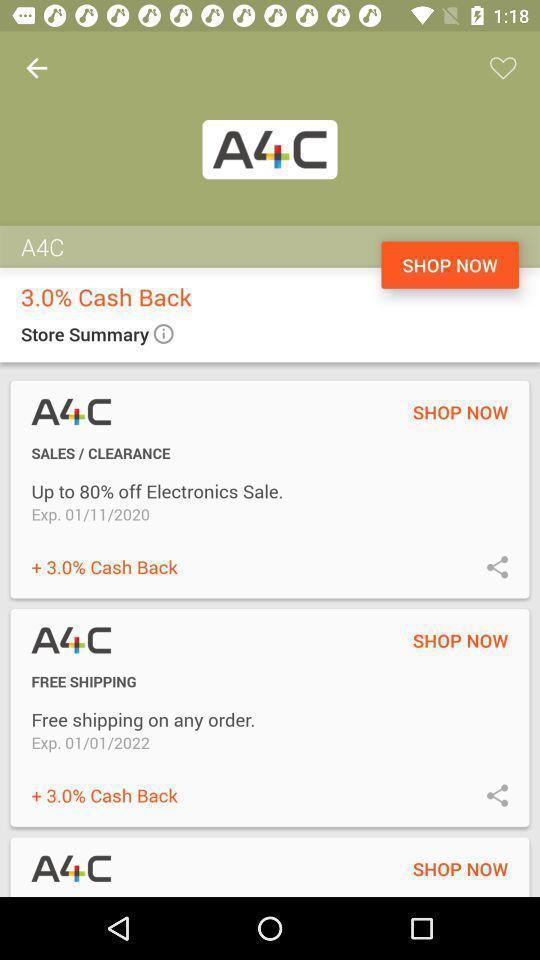Describe the visual elements of this screenshot. Page showing info in a shopping deals app. 